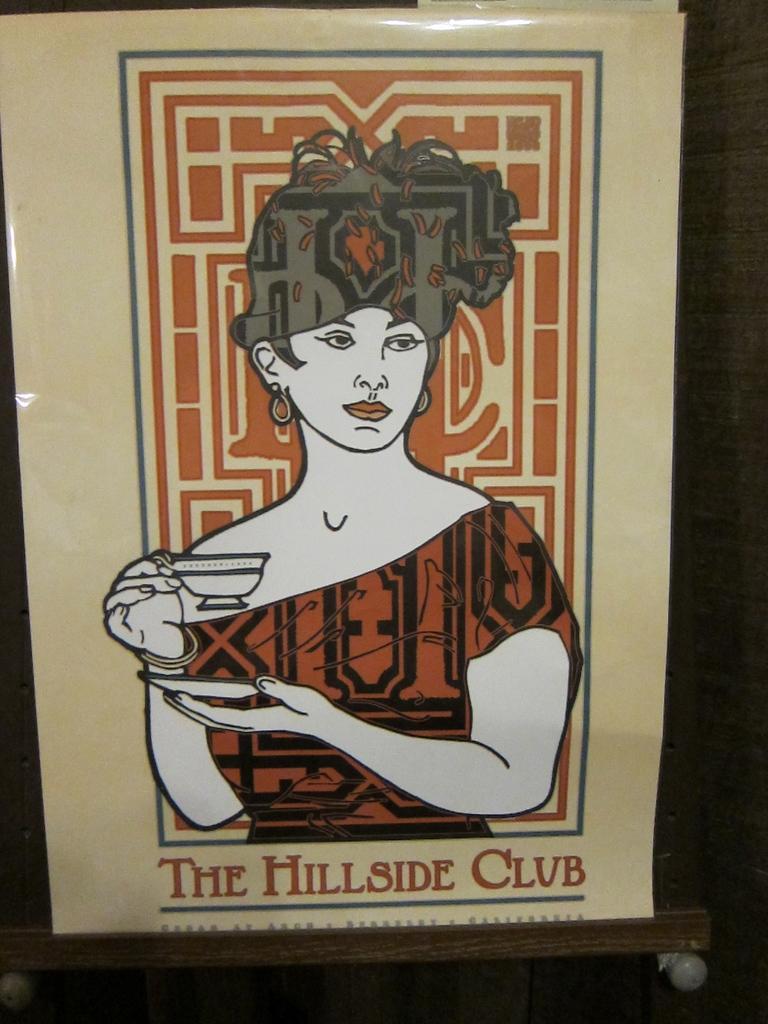Describe this image in one or two sentences. In the image we can see a poster on a wall. 